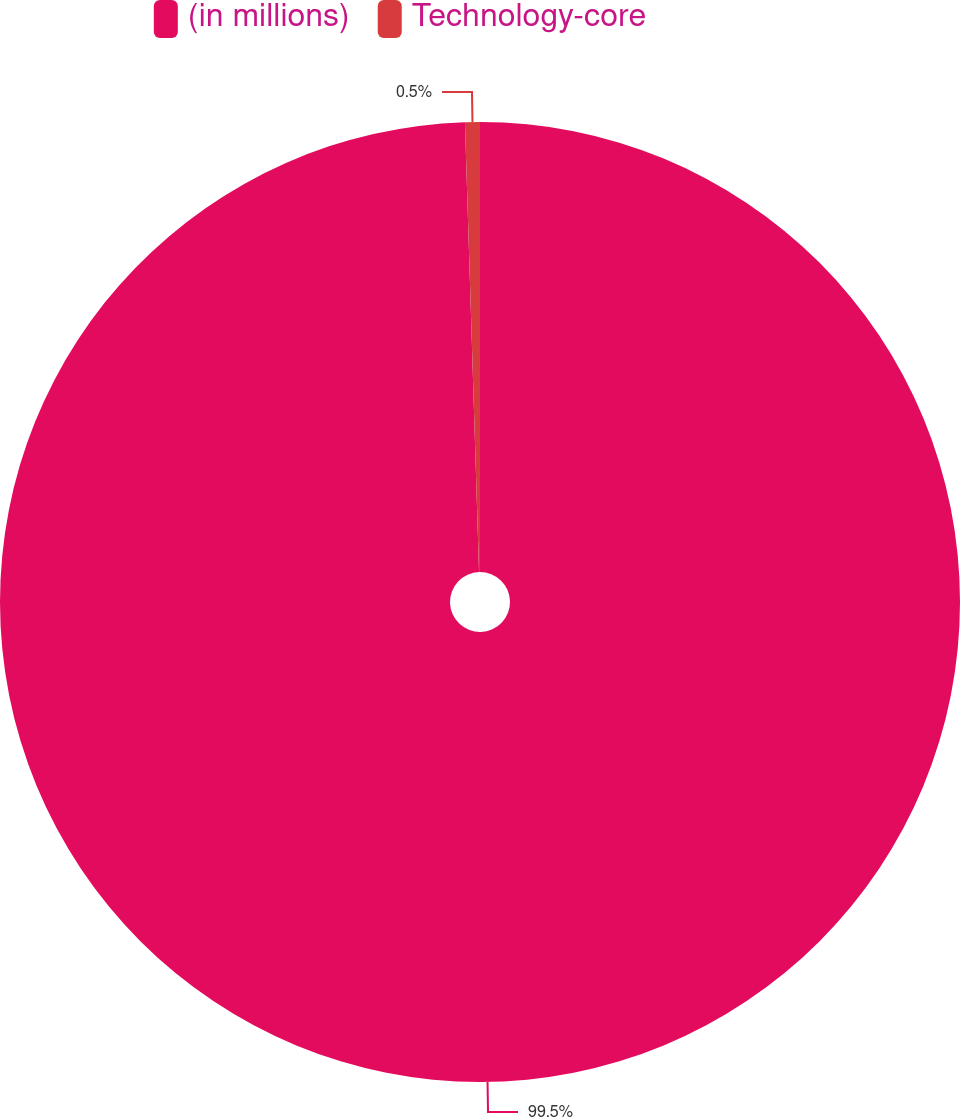Convert chart. <chart><loc_0><loc_0><loc_500><loc_500><pie_chart><fcel>(in millions)<fcel>Technology-core<nl><fcel>99.5%<fcel>0.5%<nl></chart> 